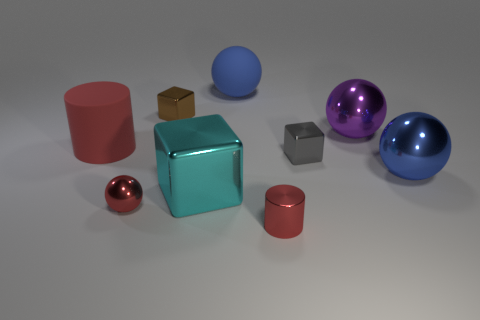Which object seems out of place in this group and why? The small brown cardboard box appears somewhat out of place among the other objects. While most items exhibit smooth and shiny surfaces, the box has a textured, matte surface. Its simple and utilitarian design contrasts with the more decorative appearance of the colorful spheres and cylinders, making it stand out as unique in this setting. 